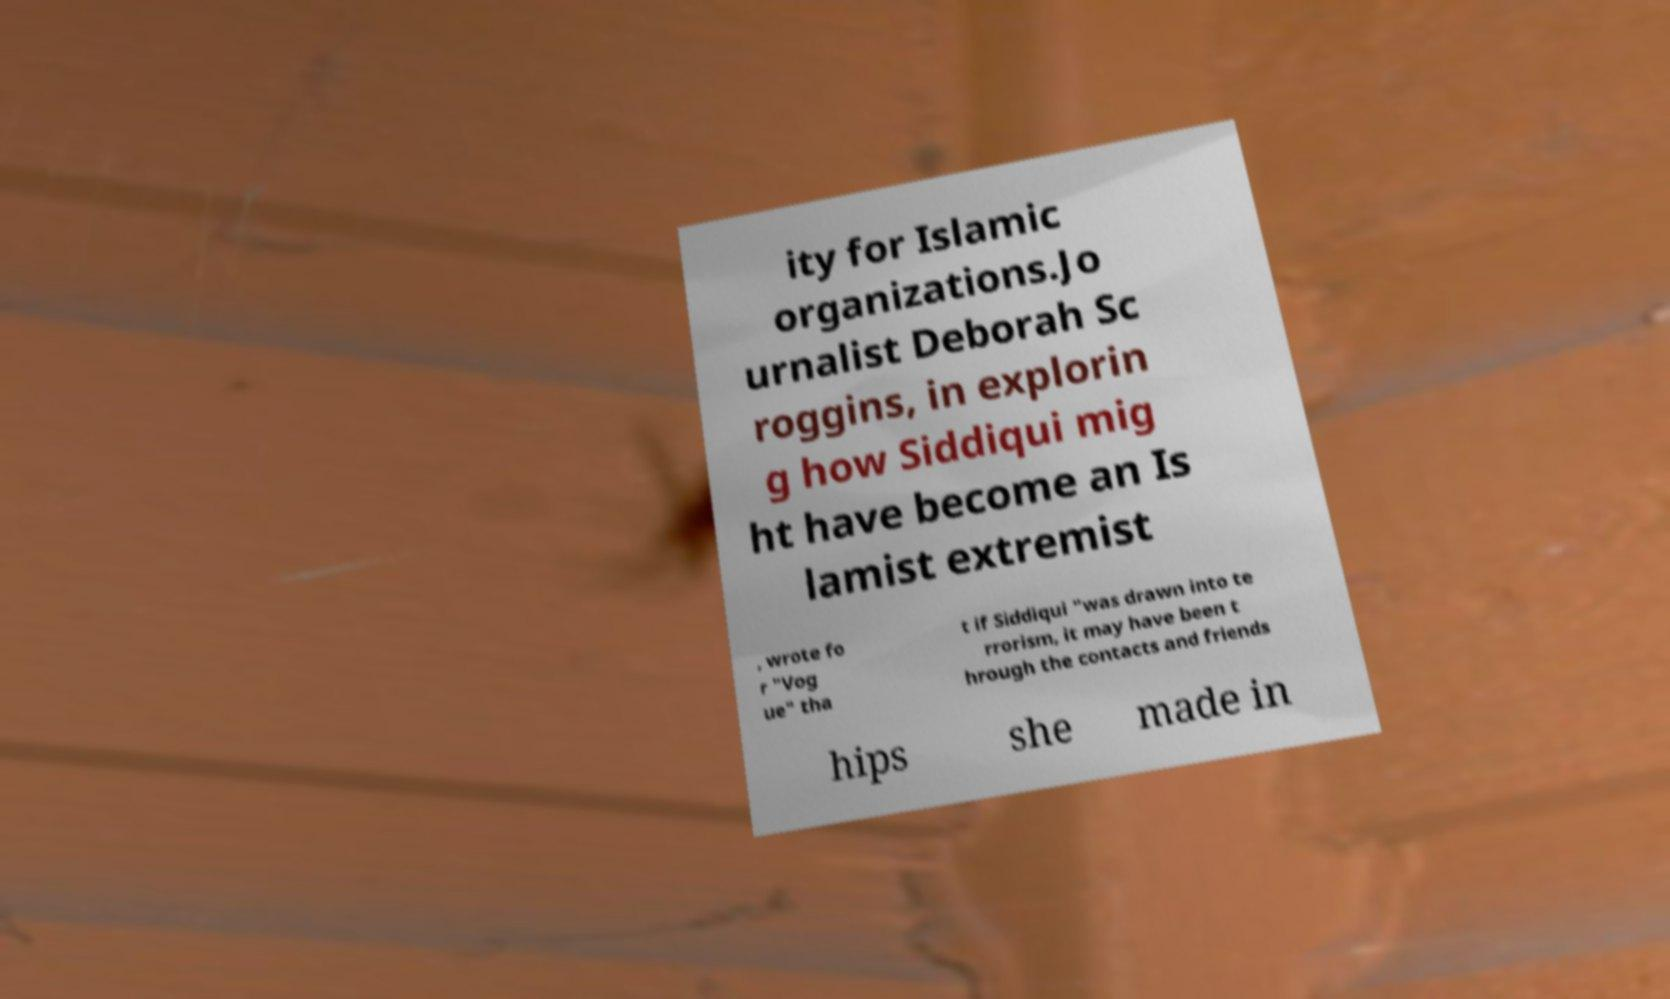Can you accurately transcribe the text from the provided image for me? ity for Islamic organizations.Jo urnalist Deborah Sc roggins, in explorin g how Siddiqui mig ht have become an Is lamist extremist , wrote fo r "Vog ue" tha t if Siddiqui "was drawn into te rrorism, it may have been t hrough the contacts and friends hips she made in 